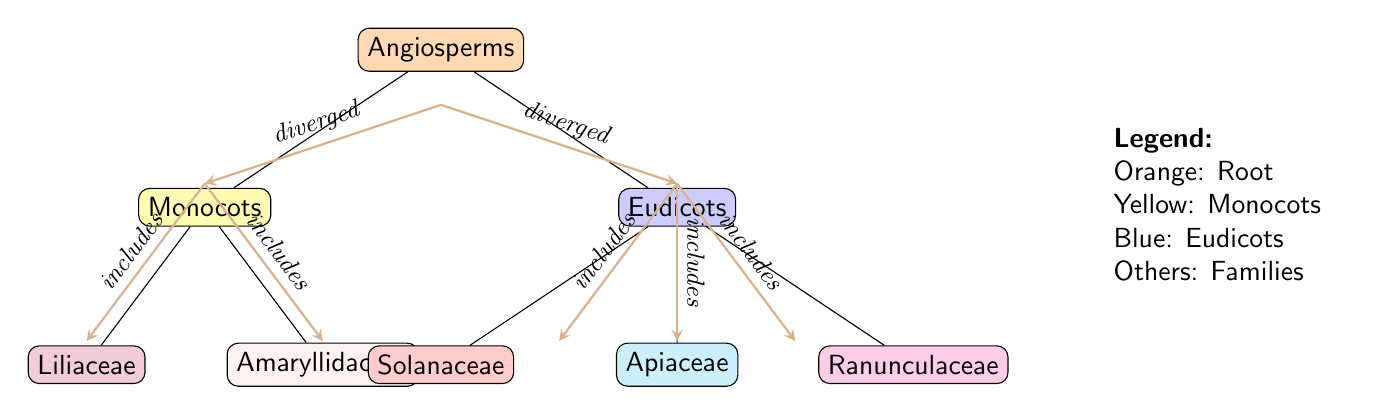What is the root of the phylogenetic tree? The root of the tree is represented by the topmost node, labeled as "Angiosperms." This designation indicates the broader category from which all subsequent branches (such as Monocots and Eudicots) diverge.
Answer: Angiosperms How many main branches are there coming from the root? From the "Angiosperms" node, there are two main branches depicted: "Monocots" and "Eudicots." Each of these branches represents a significant lineage within the angiosperms.
Answer: 2 Which family is included under Monocots? Under the "Monocots" branch, there are two families shown: "Liliaceae" and "Amaryllidaceae." Both are specific families of plants belonging to the monocotyledon group.
Answer: Liliaceae and Amaryllidaceae What does the edge between "Monocots" and "Eudicots" signify? The edge connecting "Monocots" and "Eudicots" indicates divergence, meaning these two groups split from a common ancestor in the evolutionary history of angiosperms.
Answer: diverged Which family is associated with the color blue in the diagram? The color blue represents the "Eudicots" division, indicating its association with the families contained within this category. In the diagram, connected within Eudicots is "Solanaceae."
Answer: Solanaceae How many families fall under Eudicots? The "Eudicots" node has three sub-branches: "Solanaceae," "Apiaceae," and "Ranunculaceae," thereby indicating that there are three distinct families represented under Eudicots.
Answer: 3 What is the relationship between "Liliaceae" and "Amaryllidaceae"? Both "Liliaceae" and "Amaryllidaceae" are sub-families that branch off directly from the "Monocots" node, indicating they share a common lineage as part of the Monocots family.
Answer: includes Which family does the pink color represent? In the diagram, the pink color corresponds to the "Amaryllidaceae" family, a specific family within the monocots that is distinguished visually by this color coding.
Answer: Amaryllidaceae What do the labels on the edges of the diagram indicate? The labels on the edges, such as "diverged" and "includes," provide insight into the evolutionary relationships and classifications of the plant families represented in the diagram, adding context to the connections between nodes.
Answer: diverged and includes 